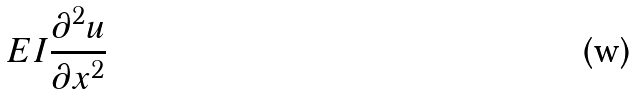Convert formula to latex. <formula><loc_0><loc_0><loc_500><loc_500>E I \frac { \partial ^ { 2 } u } { \partial x ^ { 2 } }</formula> 